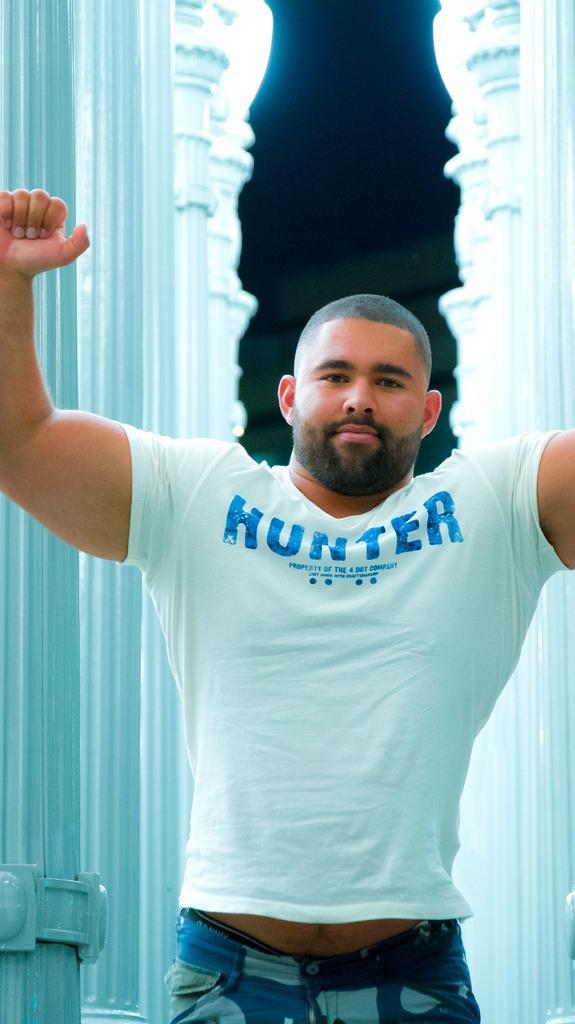In one or two sentences, can you explain what this image depicts? In this picture there is a person with white t-shirt is standing. At the back there are pillars. At the top it looks like sky and there are lights. 